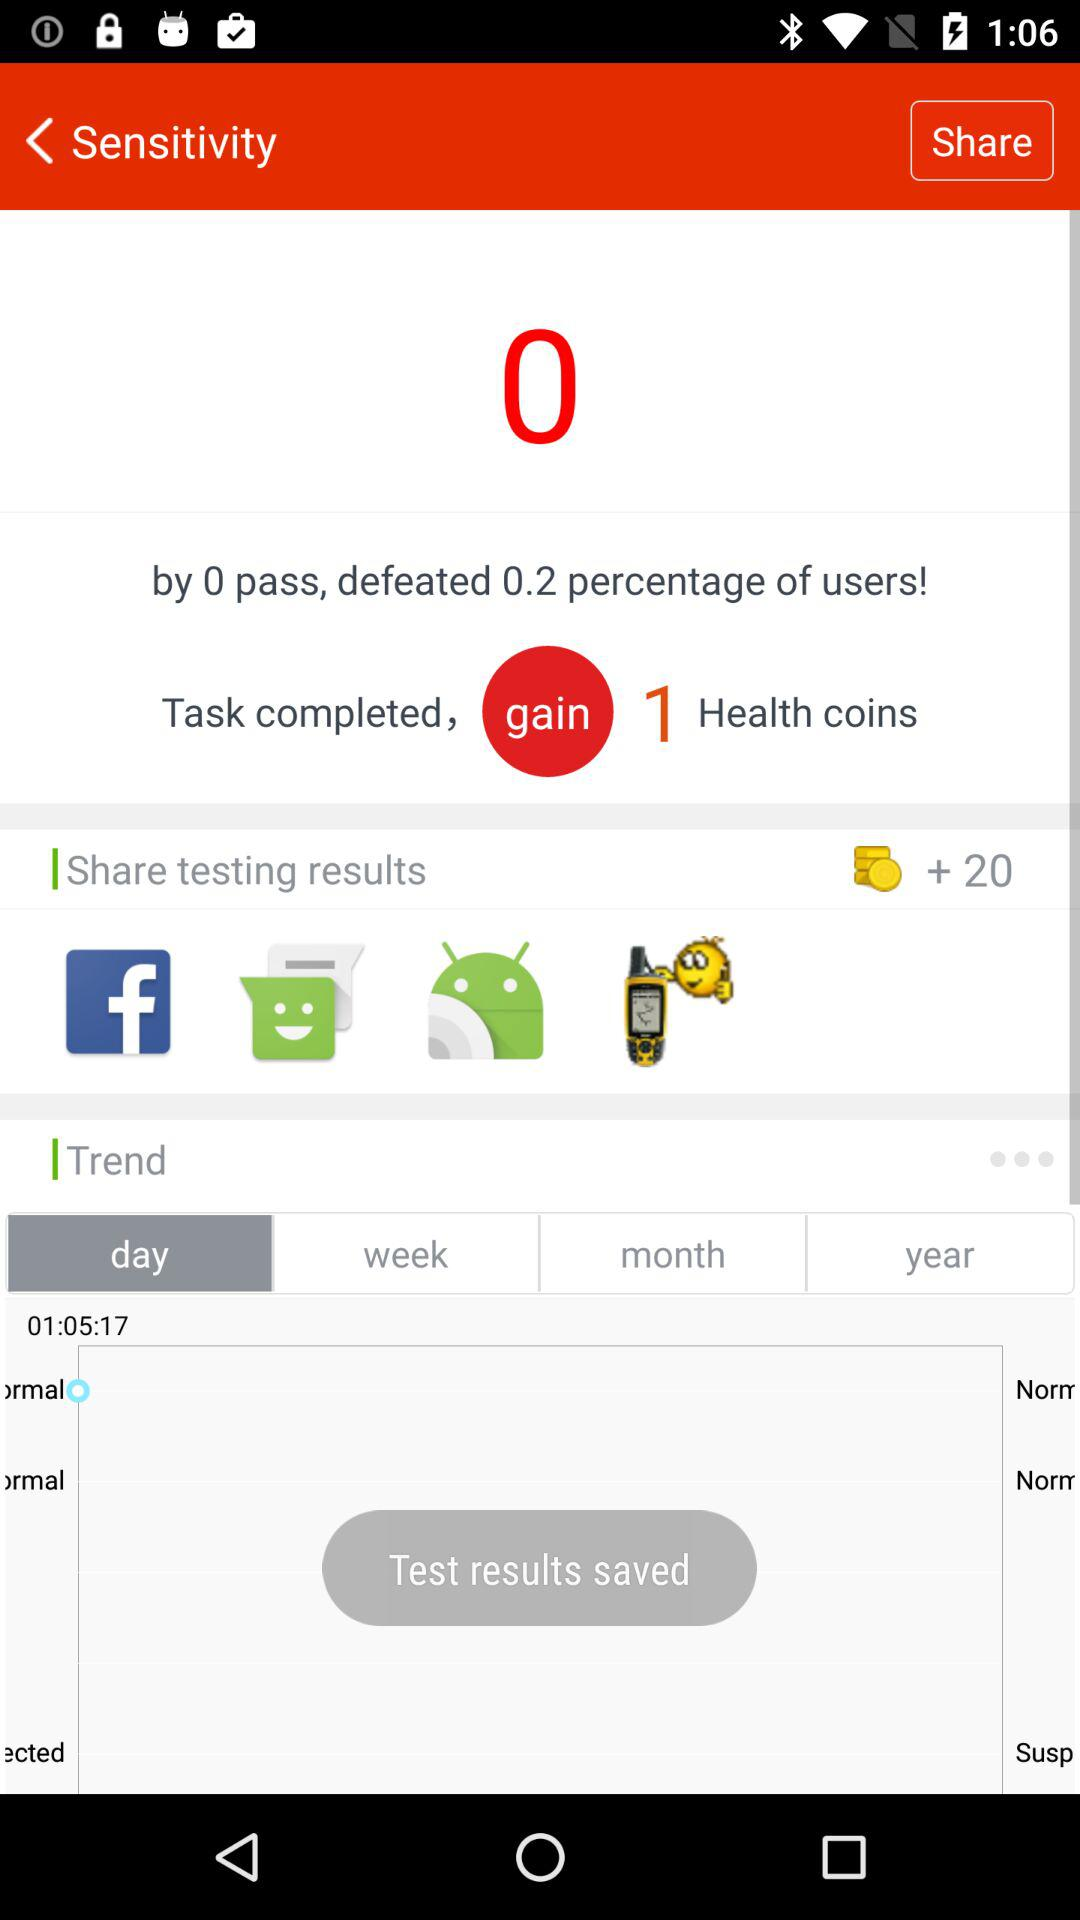What is the difference between the number of coins gained and the number of coins lost?
Answer the question using a single word or phrase. 1 